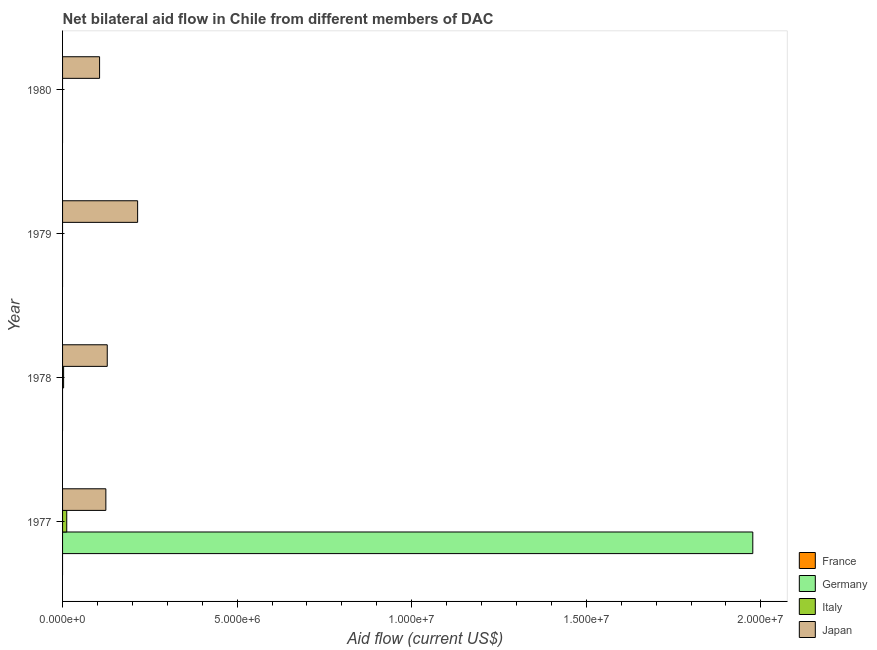How many different coloured bars are there?
Keep it short and to the point. 3. Are the number of bars per tick equal to the number of legend labels?
Provide a short and direct response. No. What is the label of the 2nd group of bars from the top?
Your answer should be very brief. 1979. What is the amount of aid given by germany in 1978?
Offer a terse response. 0. Across all years, what is the maximum amount of aid given by italy?
Offer a terse response. 1.20e+05. Across all years, what is the minimum amount of aid given by japan?
Keep it short and to the point. 1.06e+06. In which year was the amount of aid given by japan maximum?
Offer a very short reply. 1979. What is the total amount of aid given by germany in the graph?
Keep it short and to the point. 1.98e+07. What is the difference between the amount of aid given by japan in 1979 and that in 1980?
Your answer should be compact. 1.09e+06. What is the difference between the amount of aid given by france in 1980 and the amount of aid given by japan in 1978?
Offer a very short reply. -1.28e+06. What is the average amount of aid given by germany per year?
Your answer should be very brief. 4.94e+06. In the year 1977, what is the difference between the amount of aid given by japan and amount of aid given by italy?
Offer a terse response. 1.12e+06. What is the ratio of the amount of aid given by japan in 1977 to that in 1978?
Make the answer very short. 0.97. What is the difference between the highest and the second highest amount of aid given by japan?
Your answer should be compact. 8.70e+05. What is the difference between the highest and the lowest amount of aid given by japan?
Offer a very short reply. 1.09e+06. Is the sum of the amount of aid given by japan in 1978 and 1980 greater than the maximum amount of aid given by germany across all years?
Offer a very short reply. No. Are all the bars in the graph horizontal?
Ensure brevity in your answer.  Yes. How many years are there in the graph?
Your answer should be very brief. 4. What is the difference between two consecutive major ticks on the X-axis?
Your answer should be very brief. 5.00e+06. Are the values on the major ticks of X-axis written in scientific E-notation?
Offer a terse response. Yes. Does the graph contain any zero values?
Your answer should be compact. Yes. How many legend labels are there?
Make the answer very short. 4. How are the legend labels stacked?
Keep it short and to the point. Vertical. What is the title of the graph?
Provide a short and direct response. Net bilateral aid flow in Chile from different members of DAC. Does "International Monetary Fund" appear as one of the legend labels in the graph?
Your response must be concise. No. What is the Aid flow (current US$) of Germany in 1977?
Your answer should be very brief. 1.98e+07. What is the Aid flow (current US$) of Italy in 1977?
Your response must be concise. 1.20e+05. What is the Aid flow (current US$) in Japan in 1977?
Offer a terse response. 1.24e+06. What is the Aid flow (current US$) in Japan in 1978?
Keep it short and to the point. 1.28e+06. What is the Aid flow (current US$) of Germany in 1979?
Ensure brevity in your answer.  0. What is the Aid flow (current US$) of Italy in 1979?
Your response must be concise. 0. What is the Aid flow (current US$) in Japan in 1979?
Give a very brief answer. 2.15e+06. What is the Aid flow (current US$) in France in 1980?
Provide a succinct answer. 0. What is the Aid flow (current US$) of Japan in 1980?
Offer a terse response. 1.06e+06. Across all years, what is the maximum Aid flow (current US$) of Germany?
Your answer should be compact. 1.98e+07. Across all years, what is the maximum Aid flow (current US$) of Japan?
Your response must be concise. 2.15e+06. Across all years, what is the minimum Aid flow (current US$) in Germany?
Give a very brief answer. 0. Across all years, what is the minimum Aid flow (current US$) in Japan?
Your answer should be compact. 1.06e+06. What is the total Aid flow (current US$) in Germany in the graph?
Offer a terse response. 1.98e+07. What is the total Aid flow (current US$) in Italy in the graph?
Offer a terse response. 1.50e+05. What is the total Aid flow (current US$) in Japan in the graph?
Give a very brief answer. 5.73e+06. What is the difference between the Aid flow (current US$) in Italy in 1977 and that in 1978?
Your answer should be very brief. 9.00e+04. What is the difference between the Aid flow (current US$) in Japan in 1977 and that in 1978?
Provide a short and direct response. -4.00e+04. What is the difference between the Aid flow (current US$) in Japan in 1977 and that in 1979?
Keep it short and to the point. -9.10e+05. What is the difference between the Aid flow (current US$) in Japan in 1978 and that in 1979?
Your answer should be very brief. -8.70e+05. What is the difference between the Aid flow (current US$) in Japan in 1979 and that in 1980?
Offer a very short reply. 1.09e+06. What is the difference between the Aid flow (current US$) in Germany in 1977 and the Aid flow (current US$) in Italy in 1978?
Offer a very short reply. 1.97e+07. What is the difference between the Aid flow (current US$) of Germany in 1977 and the Aid flow (current US$) of Japan in 1978?
Give a very brief answer. 1.85e+07. What is the difference between the Aid flow (current US$) in Italy in 1977 and the Aid flow (current US$) in Japan in 1978?
Provide a short and direct response. -1.16e+06. What is the difference between the Aid flow (current US$) of Germany in 1977 and the Aid flow (current US$) of Japan in 1979?
Offer a terse response. 1.76e+07. What is the difference between the Aid flow (current US$) of Italy in 1977 and the Aid flow (current US$) of Japan in 1979?
Offer a terse response. -2.03e+06. What is the difference between the Aid flow (current US$) in Germany in 1977 and the Aid flow (current US$) in Japan in 1980?
Ensure brevity in your answer.  1.87e+07. What is the difference between the Aid flow (current US$) of Italy in 1977 and the Aid flow (current US$) of Japan in 1980?
Offer a very short reply. -9.40e+05. What is the difference between the Aid flow (current US$) in Italy in 1978 and the Aid flow (current US$) in Japan in 1979?
Offer a terse response. -2.12e+06. What is the difference between the Aid flow (current US$) of Italy in 1978 and the Aid flow (current US$) of Japan in 1980?
Offer a very short reply. -1.03e+06. What is the average Aid flow (current US$) of Germany per year?
Offer a terse response. 4.94e+06. What is the average Aid flow (current US$) in Italy per year?
Keep it short and to the point. 3.75e+04. What is the average Aid flow (current US$) in Japan per year?
Your answer should be very brief. 1.43e+06. In the year 1977, what is the difference between the Aid flow (current US$) of Germany and Aid flow (current US$) of Italy?
Keep it short and to the point. 1.96e+07. In the year 1977, what is the difference between the Aid flow (current US$) in Germany and Aid flow (current US$) in Japan?
Your answer should be very brief. 1.85e+07. In the year 1977, what is the difference between the Aid flow (current US$) in Italy and Aid flow (current US$) in Japan?
Keep it short and to the point. -1.12e+06. In the year 1978, what is the difference between the Aid flow (current US$) in Italy and Aid flow (current US$) in Japan?
Offer a terse response. -1.25e+06. What is the ratio of the Aid flow (current US$) of Italy in 1977 to that in 1978?
Your response must be concise. 4. What is the ratio of the Aid flow (current US$) of Japan in 1977 to that in 1978?
Your response must be concise. 0.97. What is the ratio of the Aid flow (current US$) of Japan in 1977 to that in 1979?
Make the answer very short. 0.58. What is the ratio of the Aid flow (current US$) in Japan in 1977 to that in 1980?
Make the answer very short. 1.17. What is the ratio of the Aid flow (current US$) in Japan in 1978 to that in 1979?
Offer a very short reply. 0.6. What is the ratio of the Aid flow (current US$) of Japan in 1978 to that in 1980?
Provide a short and direct response. 1.21. What is the ratio of the Aid flow (current US$) of Japan in 1979 to that in 1980?
Make the answer very short. 2.03. What is the difference between the highest and the second highest Aid flow (current US$) in Japan?
Make the answer very short. 8.70e+05. What is the difference between the highest and the lowest Aid flow (current US$) of Germany?
Provide a succinct answer. 1.98e+07. What is the difference between the highest and the lowest Aid flow (current US$) in Japan?
Your answer should be compact. 1.09e+06. 